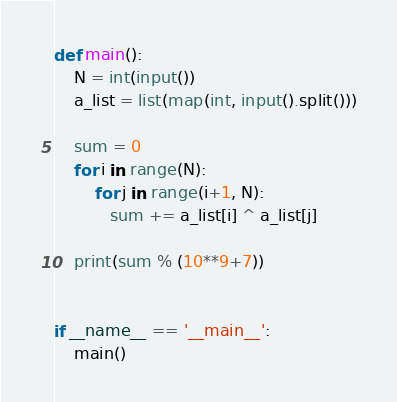Convert code to text. <code><loc_0><loc_0><loc_500><loc_500><_Python_>def main():
    N = int(input())
    a_list = list(map(int, input().split()))

    sum = 0
    for i in range(N):
        for j in range(i+1, N):
           sum += a_list[i] ^ a_list[j]

    print(sum % (10**9+7))


if __name__ == '__main__':
    main()</code> 